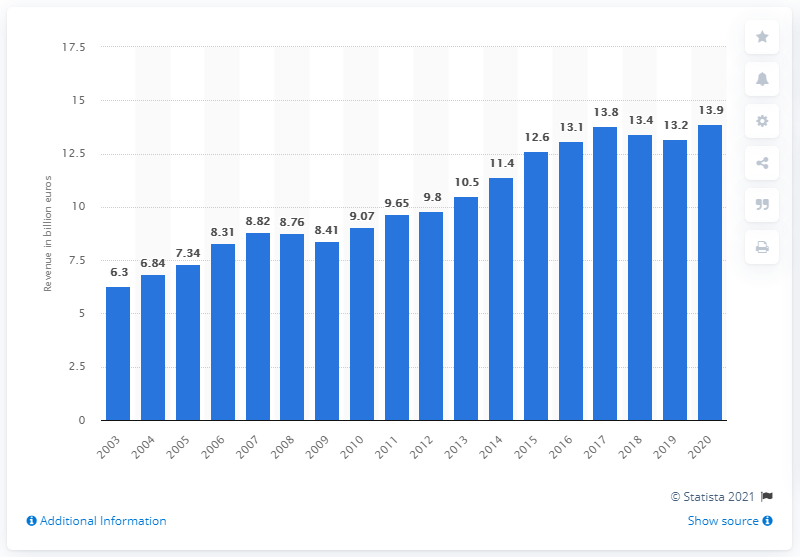Point out several critical features in this image. In 2020, the BSH Home Appliances Group's revenue was 13.9 billion U.S. dollars. The BSH Group's revenue in 2020 was 13.1 billion euros. 